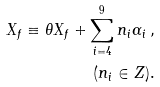Convert formula to latex. <formula><loc_0><loc_0><loc_500><loc_500>X _ { f } \equiv \theta X _ { f } + \sum ^ { 9 } _ { i = 4 } n _ { i } \alpha _ { i } \, , \\ \, ( n _ { i } \in Z ) .</formula> 